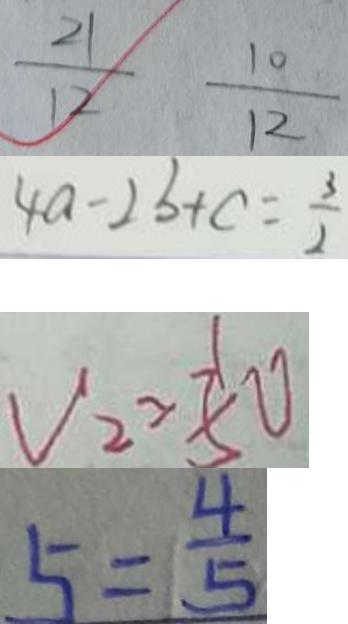<formula> <loc_0><loc_0><loc_500><loc_500>\frac { 2 1 } { 1 2 } \frac { 1 0 } { 1 2 } 
 4 a - 2 b + c = \frac { 3 } { 2 } 
 V _ { 2 } > \frac { 1 } { 5 } 0 
 5 = \frac { 4 } { 5 }</formula> 